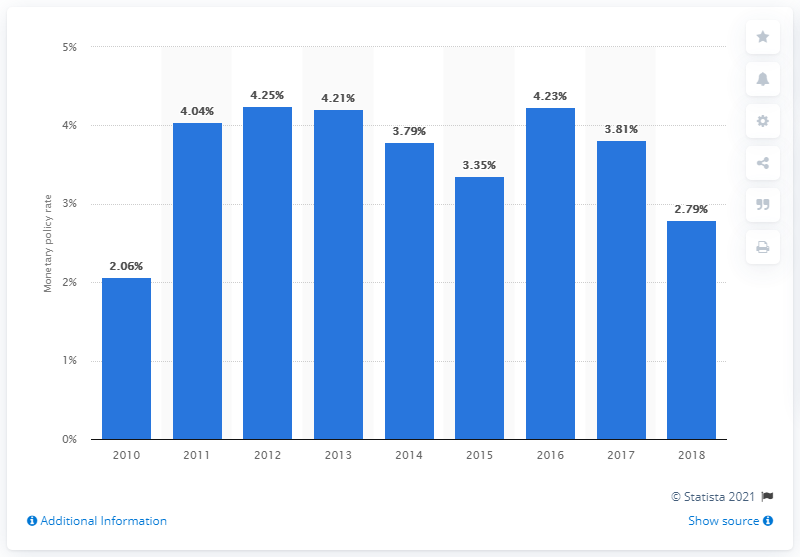Outline some significant characteristics in this image. Peru's monetary policy rate in 2018 was 2.79%. 